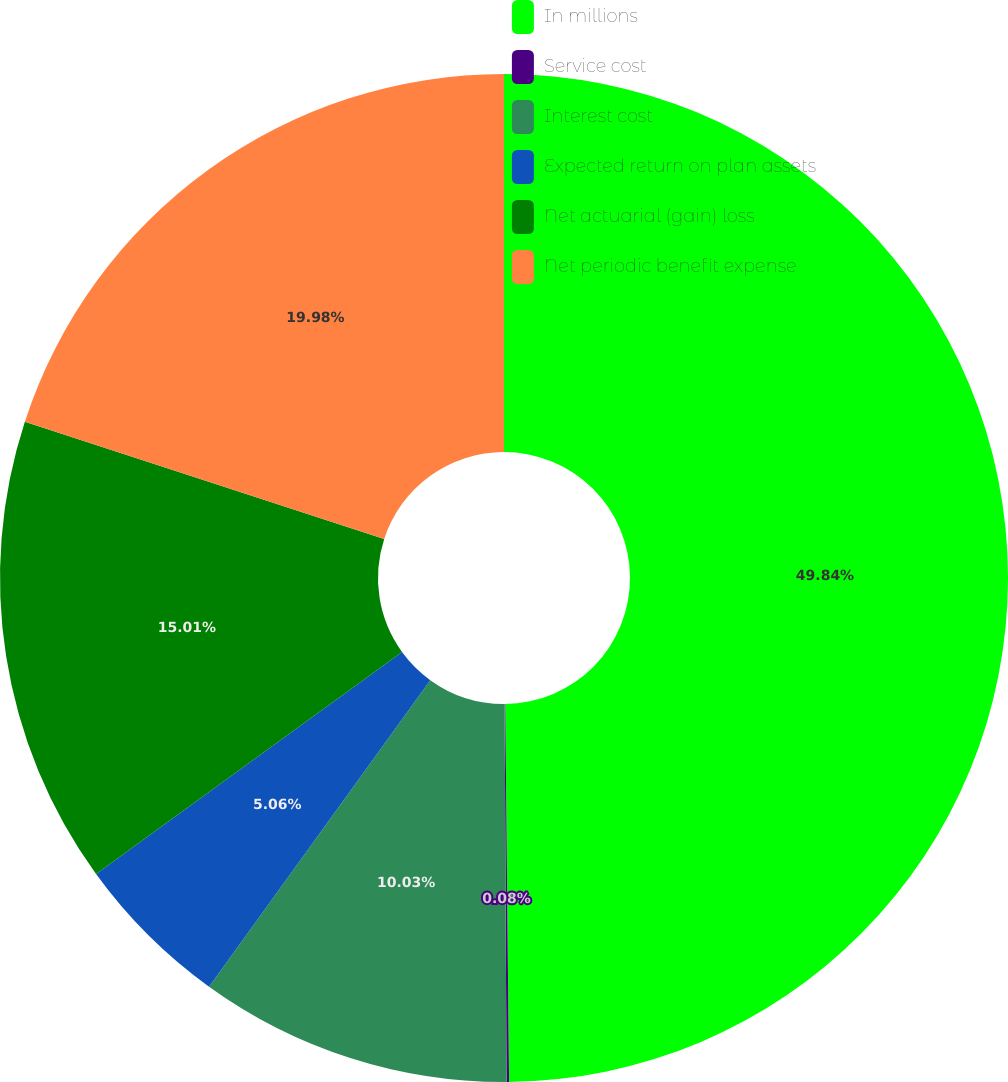<chart> <loc_0><loc_0><loc_500><loc_500><pie_chart><fcel>In millions<fcel>Service cost<fcel>Interest cost<fcel>Expected return on plan assets<fcel>Net actuarial (gain) loss<fcel>Net periodic benefit expense<nl><fcel>49.84%<fcel>0.08%<fcel>10.03%<fcel>5.06%<fcel>15.01%<fcel>19.98%<nl></chart> 